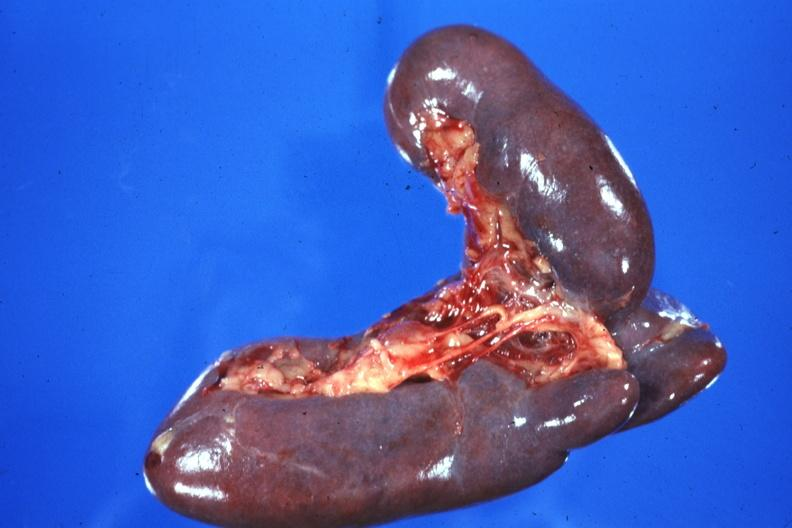s fetus developing very early present?
Answer the question using a single word or phrase. No 